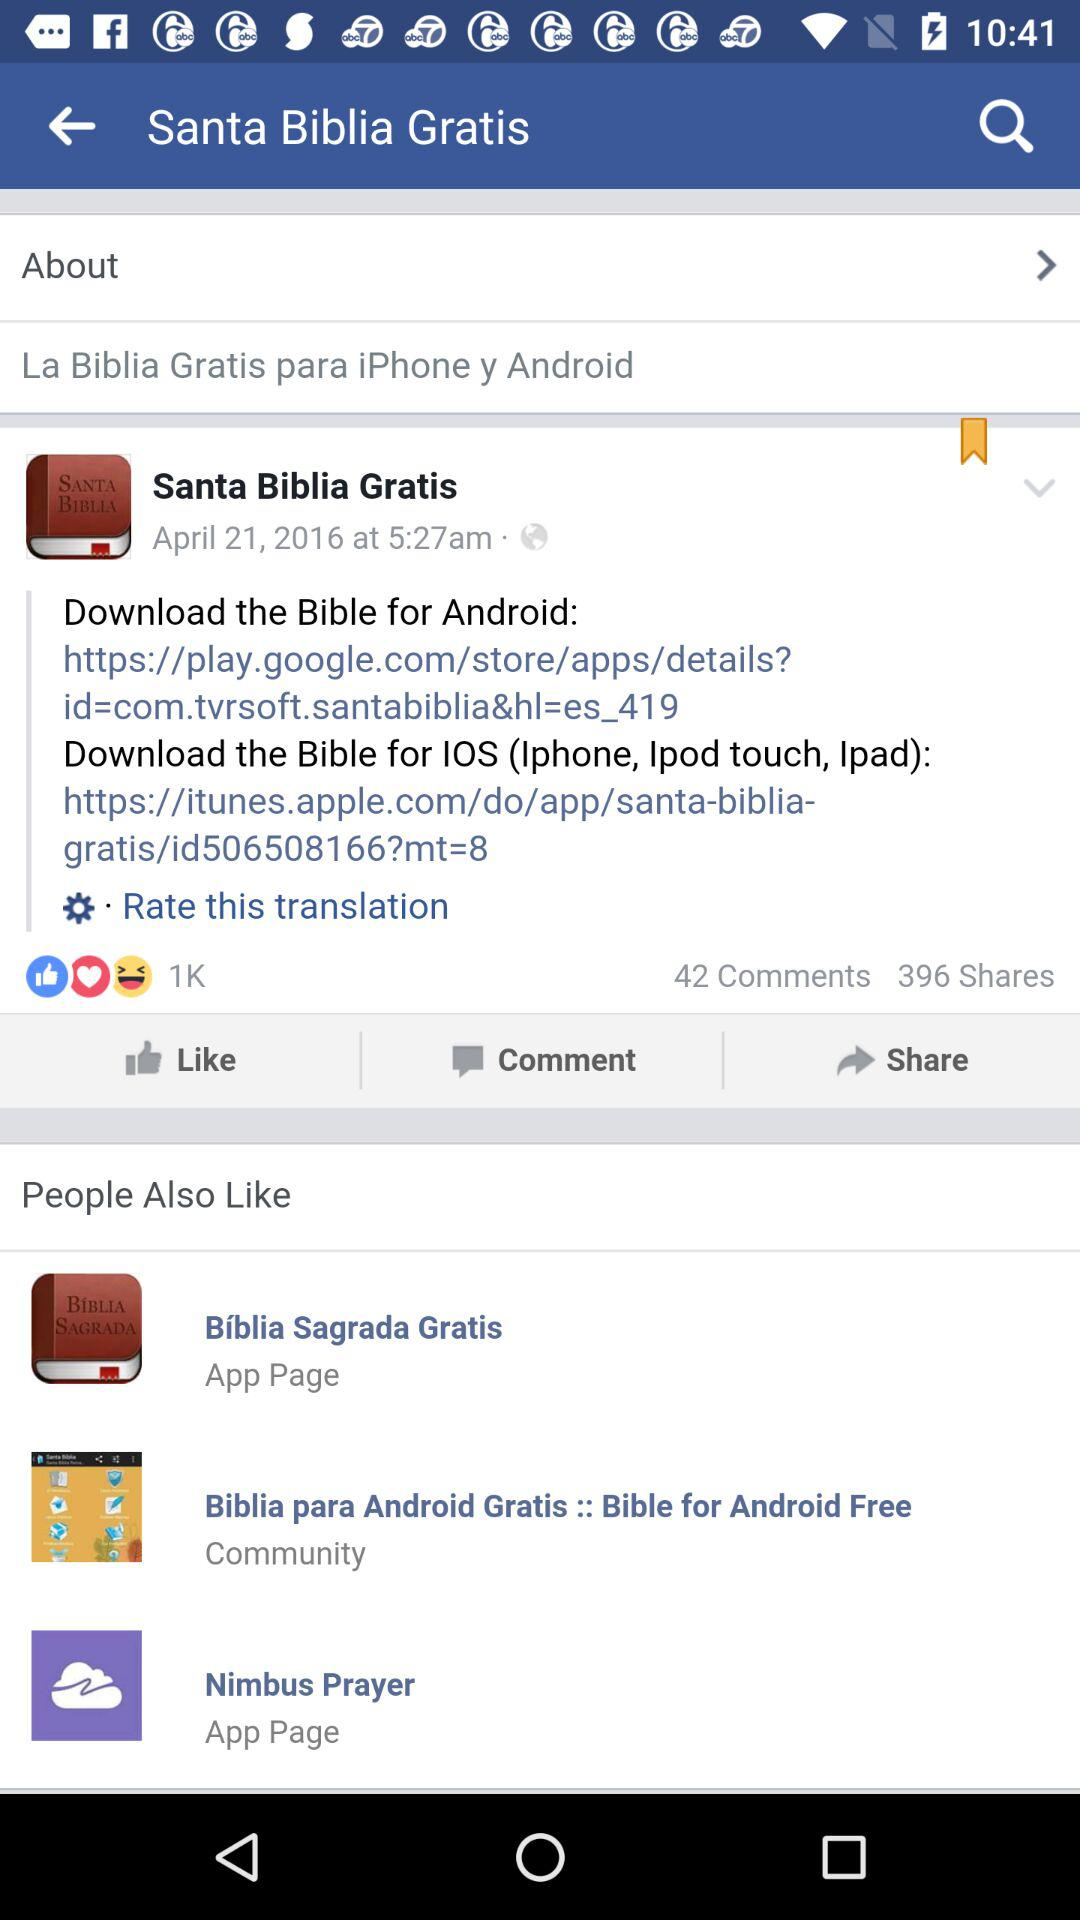What is the date of the post? The date of the post is April 21, 2016. 